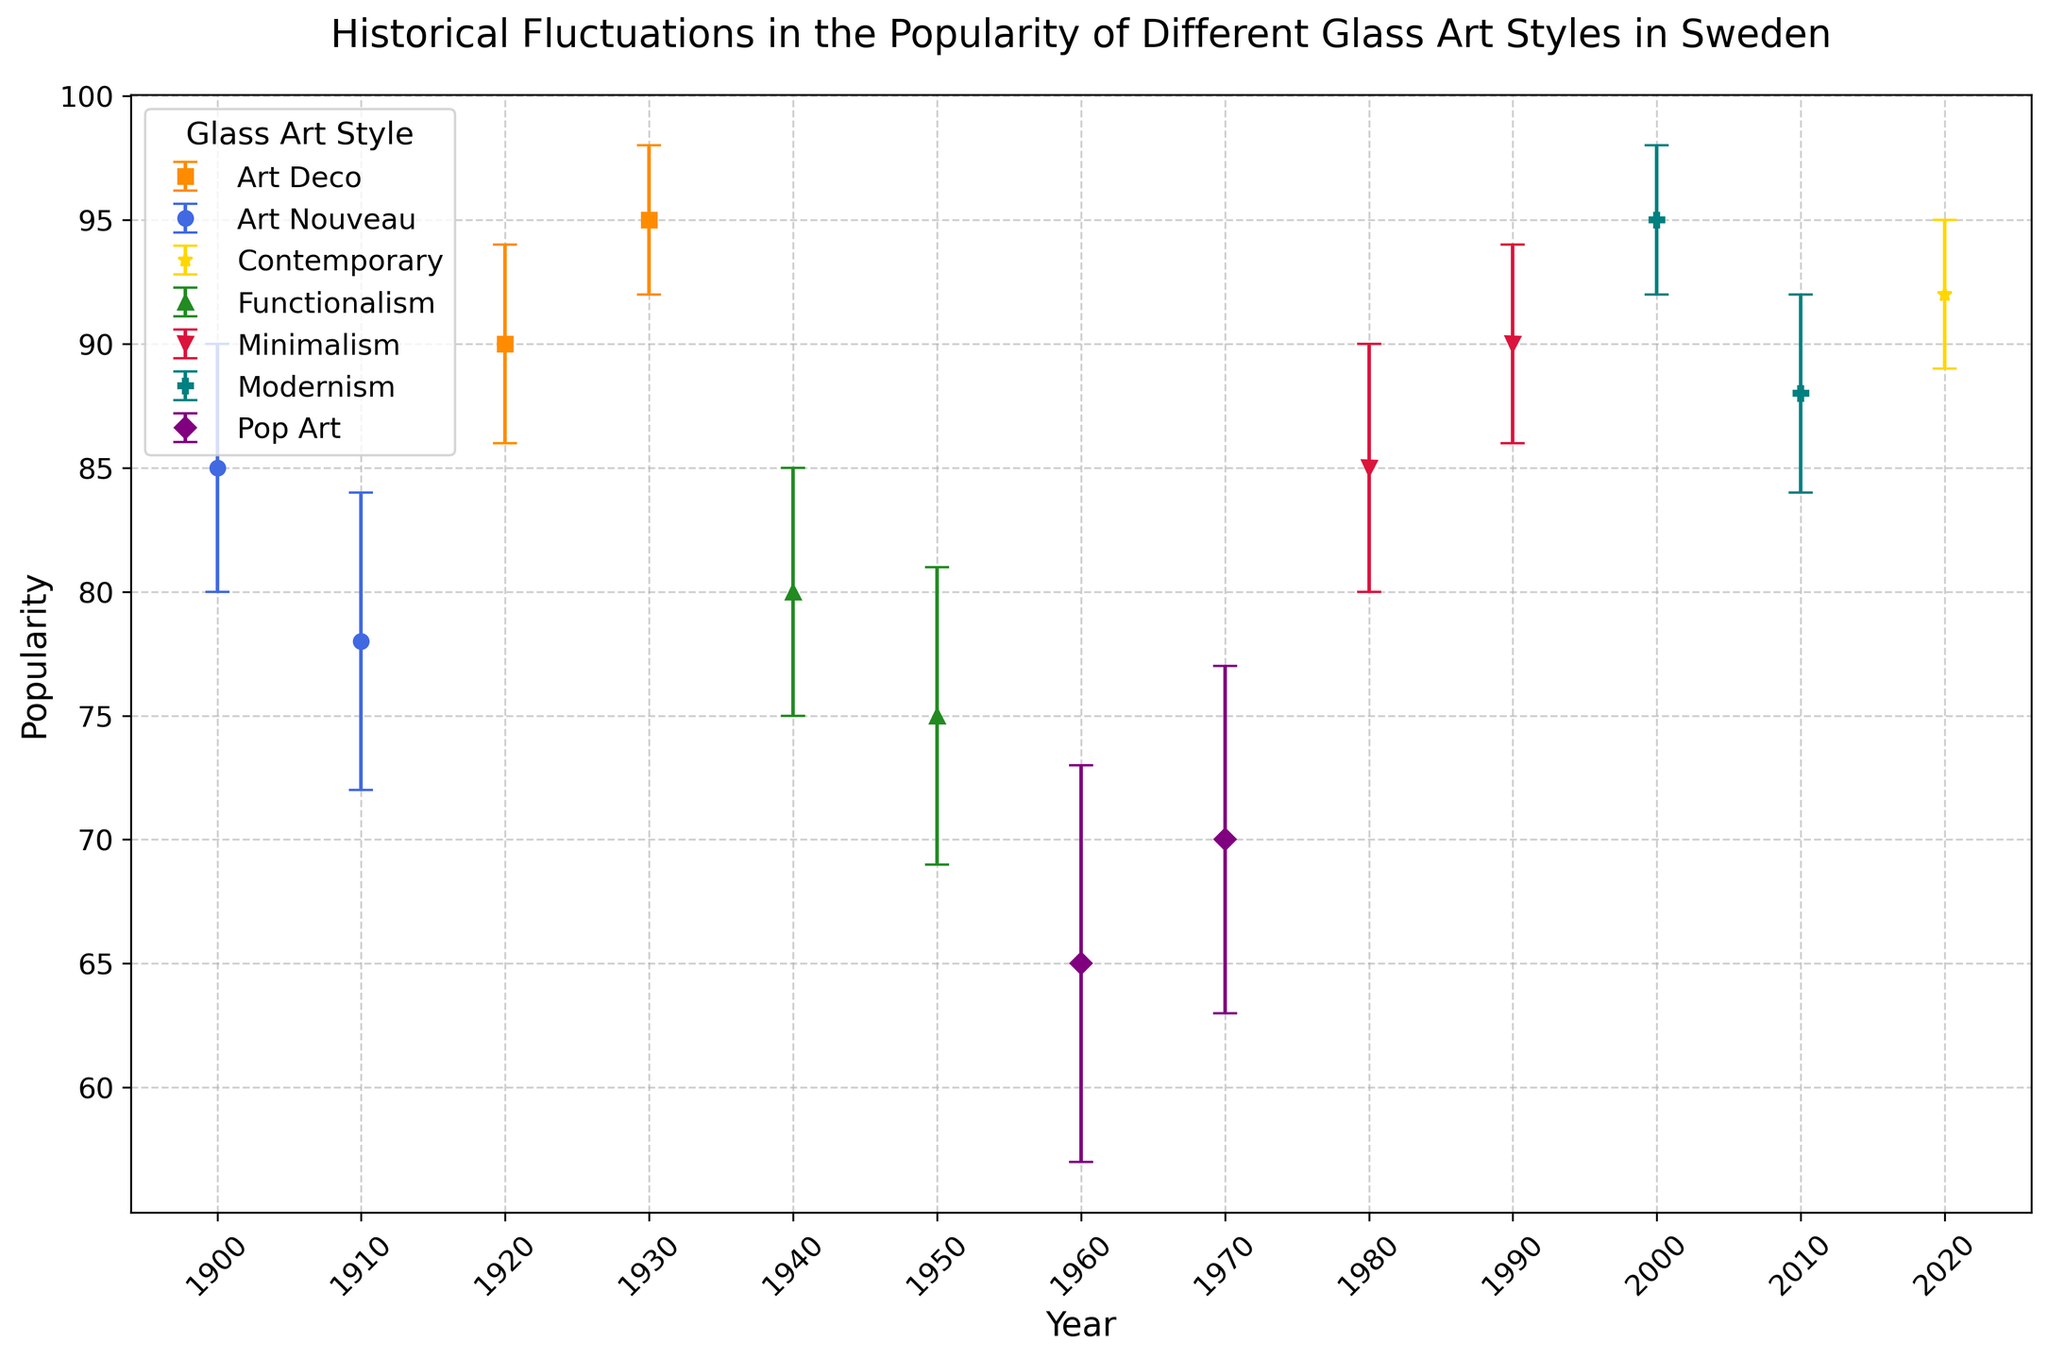What is the average popularity of Art Nouveau in the 1900s and 1910s? To find the average popularity, add the popularity values for 1900 (85) and 1910 (78), then divide by 2. (85 + 78) / 2 = 81.5
Answer: 81.5 Between which decades did Art Deco see the highest popularity? Compare the popularity of Art Deco in the 1920s (90) and the 1930s (95). The highest value is in the 1930s with a popularity of 95.
Answer: 1930s Which glass art style had the lowest popularity in the 1960s? Look for the lowest popularity value for the 1960s. Pop Art in the 1960s had a popularity of 65, which is the lowest among all styles listed for the decade.
Answer: Pop Art How does the popularity change for Functionalism between the 1940s and 1950s? Compare the popularity in the 1940s (80) and the 1950s (75). The popularity decreases from 80 to 75.
Answer: Decreased What is the difference in popularity between Modernism in the 2000s and Contemporary in the 2020s? Subtract the popularity of Contemporary in the 2020s (92) from Modernism in the 2000s (95): 95 - 92 = 3
Answer: 3 Which glass art style had the highest variation in popularity (considering the error range) and in which decade? Look for the largest error value in the data. Pop Art in the 1960s has an error of 8, the highest variation.
Answer: Pop Art in the 1960s In which decade did Minimalism reach its highest popularity? Compare the popularity values for Minimalism in the 1980s (85) and the 1990s (90). The highest value is in the 1990s with a popularity of 90.
Answer: 1990s How many years show a popularity within 5 units of 90? Look for years where the popularity is within the range (85-95). Years: 1920 (90), 1930 (95), 1980 (85), 1990 (90), 2000 (95), 2010 (88), 2020 (92) - total 7 years.
Answer: 7 